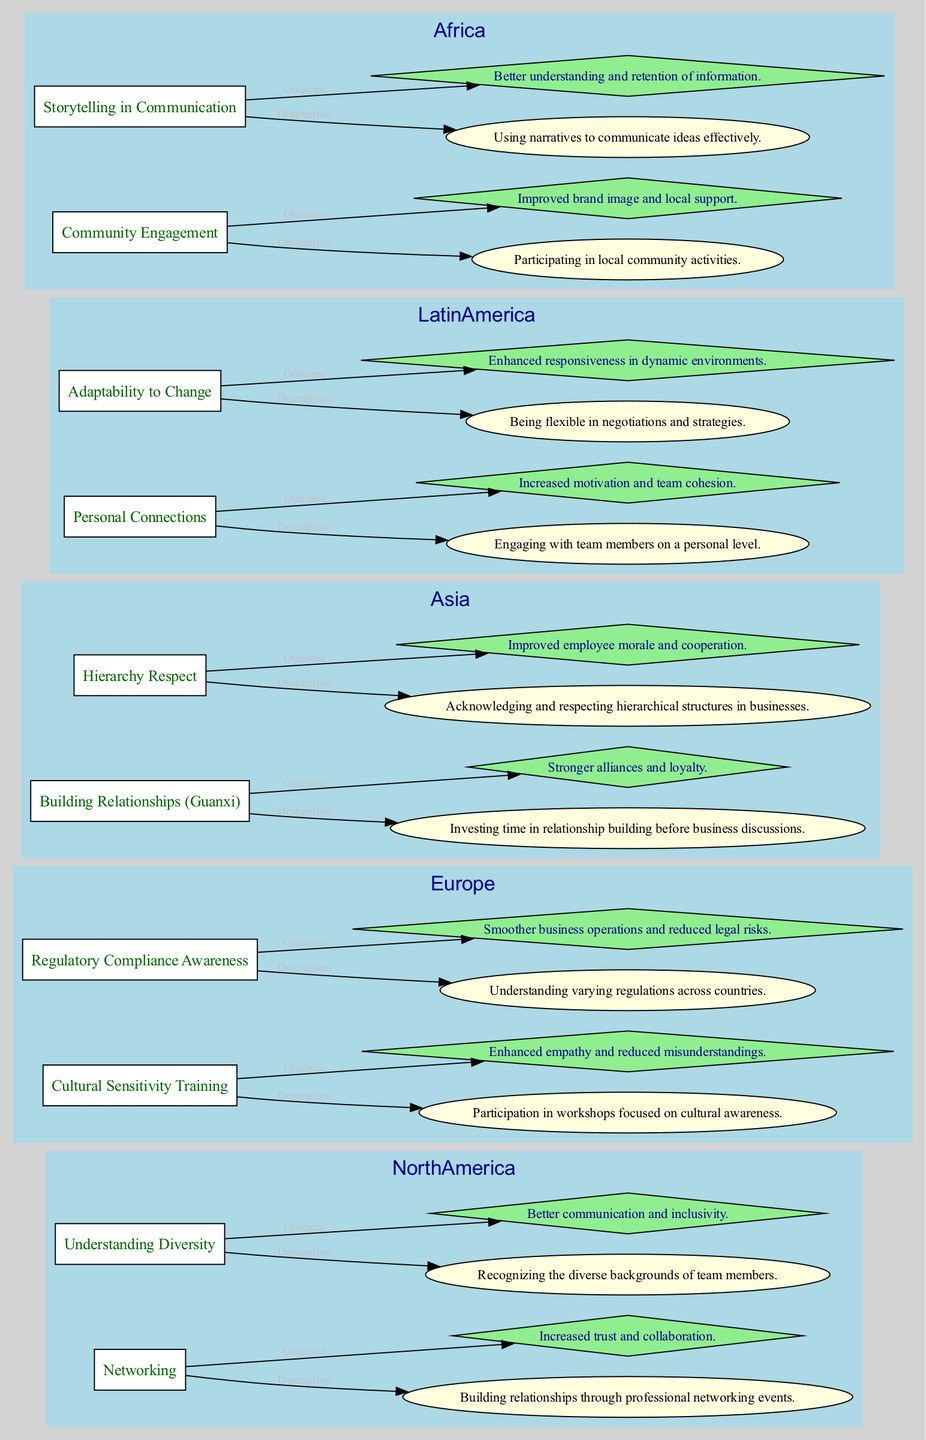What strategy is associated with "Cultural Sensitivity Training"? The question asks for the specific strategy linked to the node "Cultural Sensitivity Training” in the Europe region. By examining the diagram, this strategy directly maps to the cultural training description and outcome nodes.
Answer: Cultural Sensitivity Training How many strategies are listed under Asia? To find the number of strategies in the Asia region, we count the strategy nodes displayed within the Asia subgraph. There are two strategies: "Building Relationships (Guanxi)" and "Hierarchy Respect."
Answer: 2 What is the outcome of "Community Engagement"? This question focuses on the outcome node connected to the "Community Engagement" strategy in Africa. By reviewing the diagram, the outcome directly states the result of this strategy.
Answer: Improved brand image and local support Which region has "Personal Connections" as a strategy? The question requires identifying the region corresponding to the "Personal Connections" strategy by looking at the labels in the diagram. This strategy is present under Latin America.
Answer: Latin America What are the two outcomes listed for North America strategies? To answer, we need to identify and retrieve the outcome messages linked to the two strategies under North America. The outcomes are available by reviewing the edges connected to each strategy node for this region.
Answer: Increased trust and collaboration, Better communication and inclusivity What relationship exists between "Building Relationships (Guanxi)" and its description? The question seeks to identify the nature of the connection between the strategy and its description node for the Asia region. In the diagram, this relationship is represented as a directed edge labeled "Description" that connects the strategy node to its respective description.
Answer: Description How does "Adaptability to Change" contribute to team dynamics in Latin America? To answer, we consider both the strategy's description and the outcome, showing how being flexible in negotiations leads to enhanced responsiveness and ultimately dynamic interactions within the team. This entails analyzing the flow from the strategy to its resulting outcome in the diagram.
Answer: Enhanced responsiveness in dynamic environments What shape is used to represent strategies in the diagram? This question refers to the structure of nodes in the diagram, specifically asking for the geometric representation of strategy nodes. By inspecting the shapes associated with each strategy, we can define the standardized shape used for them.
Answer: Box Which strategy is related to storytelling? Here, the question targets the strategy that connects to the implementation of storytelling in communication, which corresponds to the African region. We can pinpoint this strategy by looking for keywords associated with narration that lead us to the respective node.
Answer: Storytelling in Communication 